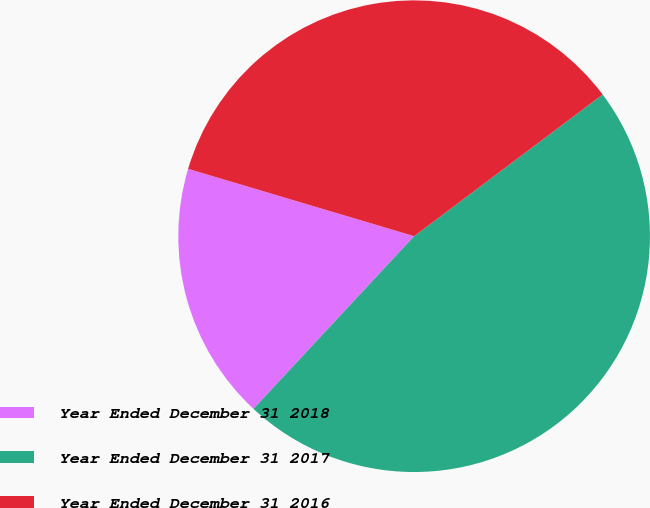Convert chart to OTSL. <chart><loc_0><loc_0><loc_500><loc_500><pie_chart><fcel>Year Ended December 31 2018<fcel>Year Ended December 31 2017<fcel>Year Ended December 31 2016<nl><fcel>17.68%<fcel>47.18%<fcel>35.13%<nl></chart> 